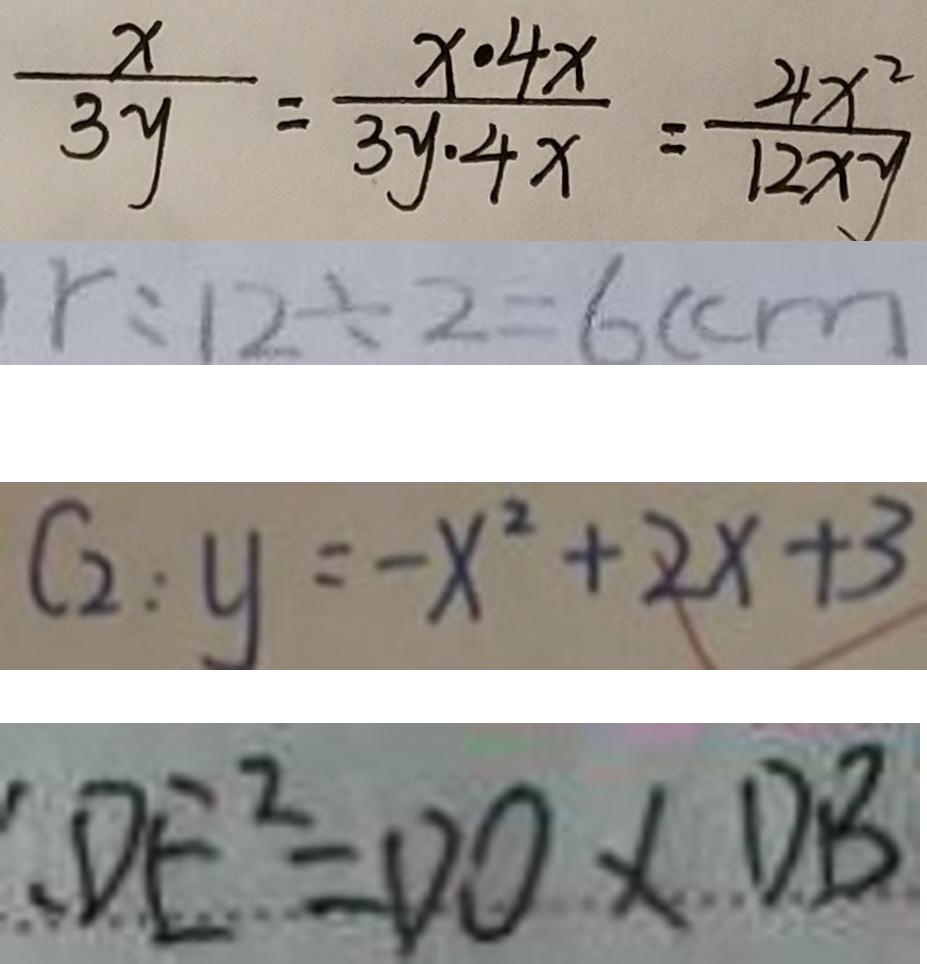Convert formula to latex. <formula><loc_0><loc_0><loc_500><loc_500>\frac { x } { 3 y } = \frac { x \cdot 4 x } { 3 y \cdot 4 x } = \frac { 4 x ^ { 2 } } { 1 2 x y } 
 r : 1 2 \div 2 = 6 ( c m 
 C _ { 2 } : y = - x ^ { 2 } + 2 x + 3 
 、 D E ^ { 2 } = D O \times D B</formula> 